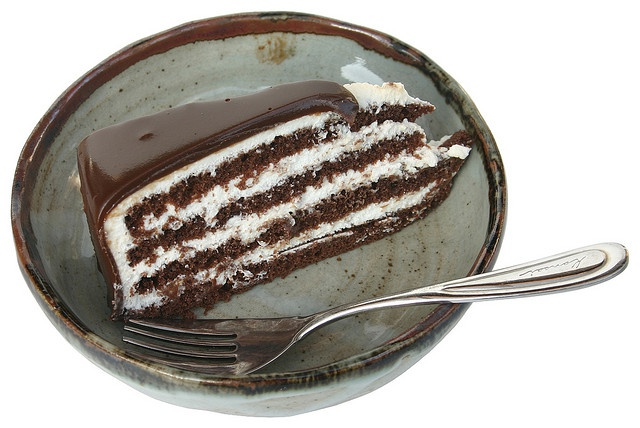Describe the objects in this image and their specific colors. I can see bowl in white, gray, darkgray, maroon, and black tones, cake in white, maroon, gray, black, and lightgray tones, and fork in white, black, gray, and darkgray tones in this image. 